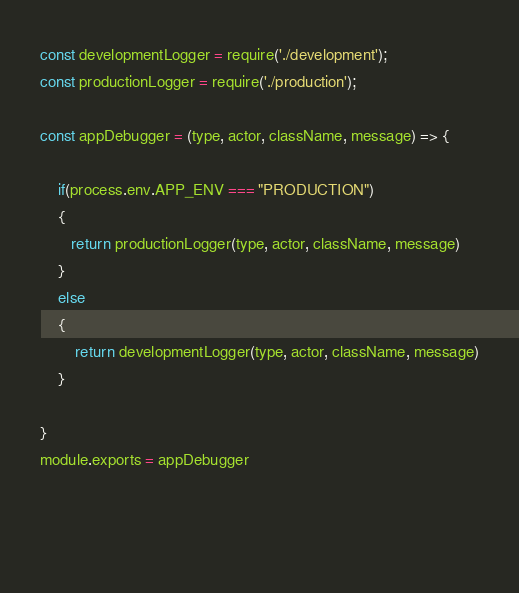<code> <loc_0><loc_0><loc_500><loc_500><_JavaScript_>const developmentLogger = require('./development');
const productionLogger = require('./production');

const appDebugger = (type, actor, className, message) => {

    if(process.env.APP_ENV === "PRODUCTION")
    {
       return productionLogger(type, actor, className, message)
    }
    else 
    {
        return developmentLogger(type, actor, className, message)
    }

}
module.exports = appDebugger

  
   </code> 